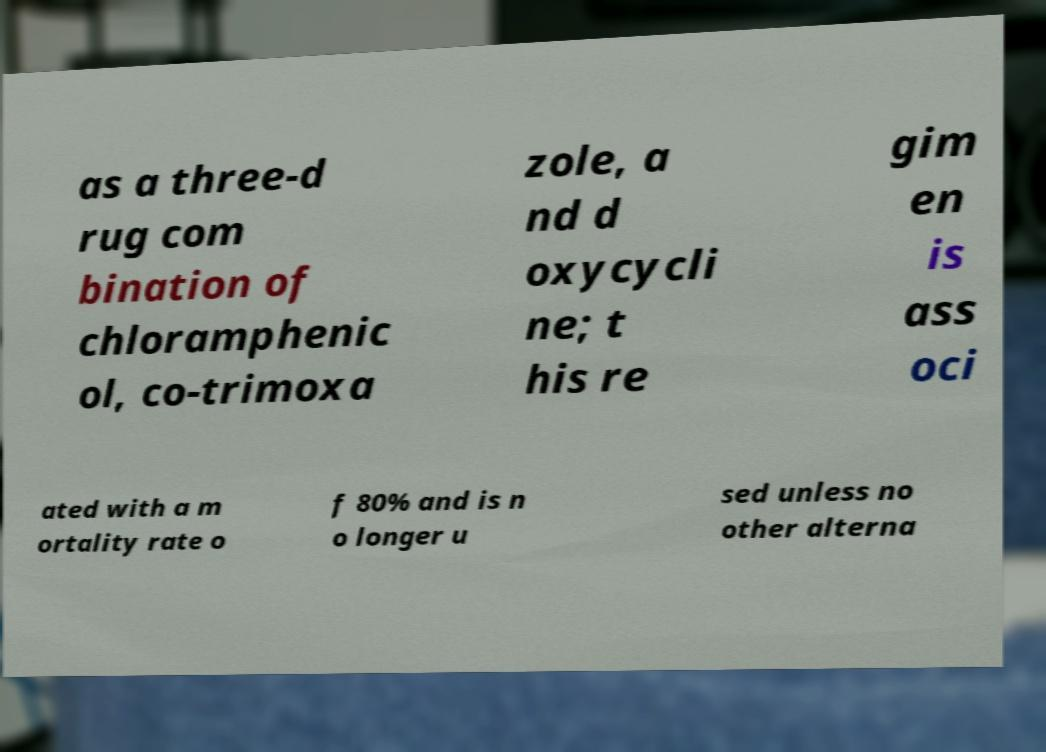Please read and relay the text visible in this image. What does it say? as a three-d rug com bination of chloramphenic ol, co-trimoxa zole, a nd d oxycycli ne; t his re gim en is ass oci ated with a m ortality rate o f 80% and is n o longer u sed unless no other alterna 